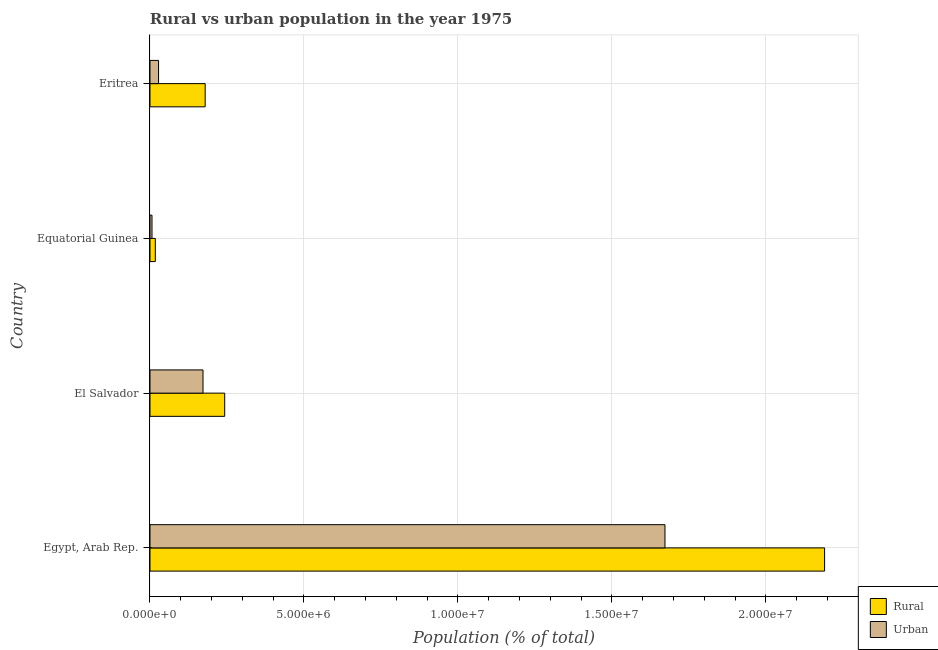How many different coloured bars are there?
Your answer should be very brief. 2. How many groups of bars are there?
Provide a succinct answer. 4. What is the label of the 2nd group of bars from the top?
Make the answer very short. Equatorial Guinea. In how many cases, is the number of bars for a given country not equal to the number of legend labels?
Provide a short and direct response. 0. What is the urban population density in Eritrea?
Your response must be concise. 2.79e+05. Across all countries, what is the maximum rural population density?
Your answer should be compact. 2.19e+07. Across all countries, what is the minimum urban population density?
Offer a terse response. 6.53e+04. In which country was the urban population density maximum?
Your response must be concise. Egypt, Arab Rep. In which country was the urban population density minimum?
Make the answer very short. Equatorial Guinea. What is the total urban population density in the graph?
Provide a succinct answer. 1.88e+07. What is the difference between the rural population density in El Salvador and that in Eritrea?
Your answer should be very brief. 6.34e+05. What is the difference between the urban population density in Eritrea and the rural population density in Egypt, Arab Rep.?
Make the answer very short. -2.16e+07. What is the average rural population density per country?
Give a very brief answer. 6.57e+06. What is the difference between the rural population density and urban population density in Eritrea?
Keep it short and to the point. 1.51e+06. In how many countries, is the rural population density greater than 8000000 %?
Ensure brevity in your answer.  1. What is the ratio of the urban population density in El Salvador to that in Equatorial Guinea?
Provide a succinct answer. 26.36. Is the rural population density in Egypt, Arab Rep. less than that in El Salvador?
Ensure brevity in your answer.  No. What is the difference between the highest and the second highest rural population density?
Your answer should be very brief. 1.95e+07. What is the difference between the highest and the lowest urban population density?
Your answer should be compact. 1.67e+07. In how many countries, is the rural population density greater than the average rural population density taken over all countries?
Keep it short and to the point. 1. Is the sum of the urban population density in Egypt, Arab Rep. and Equatorial Guinea greater than the maximum rural population density across all countries?
Give a very brief answer. No. What does the 1st bar from the top in Egypt, Arab Rep. represents?
Give a very brief answer. Urban. What does the 2nd bar from the bottom in Eritrea represents?
Offer a terse response. Urban. Are all the bars in the graph horizontal?
Provide a short and direct response. Yes. What is the difference between two consecutive major ticks on the X-axis?
Your answer should be very brief. 5.00e+06. Are the values on the major ticks of X-axis written in scientific E-notation?
Keep it short and to the point. Yes. Does the graph contain any zero values?
Ensure brevity in your answer.  No. Where does the legend appear in the graph?
Give a very brief answer. Bottom right. How are the legend labels stacked?
Provide a succinct answer. Vertical. What is the title of the graph?
Make the answer very short. Rural vs urban population in the year 1975. What is the label or title of the X-axis?
Provide a succinct answer. Population (% of total). What is the label or title of the Y-axis?
Make the answer very short. Country. What is the Population (% of total) in Rural in Egypt, Arab Rep.?
Offer a very short reply. 2.19e+07. What is the Population (% of total) in Urban in Egypt, Arab Rep.?
Keep it short and to the point. 1.67e+07. What is the Population (% of total) of Rural in El Salvador?
Provide a short and direct response. 2.43e+06. What is the Population (% of total) of Urban in El Salvador?
Offer a terse response. 1.72e+06. What is the Population (% of total) in Rural in Equatorial Guinea?
Ensure brevity in your answer.  1.73e+05. What is the Population (% of total) of Urban in Equatorial Guinea?
Provide a succinct answer. 6.53e+04. What is the Population (% of total) of Rural in Eritrea?
Provide a short and direct response. 1.79e+06. What is the Population (% of total) in Urban in Eritrea?
Offer a very short reply. 2.79e+05. Across all countries, what is the maximum Population (% of total) of Rural?
Your answer should be compact. 2.19e+07. Across all countries, what is the maximum Population (% of total) in Urban?
Keep it short and to the point. 1.67e+07. Across all countries, what is the minimum Population (% of total) of Rural?
Make the answer very short. 1.73e+05. Across all countries, what is the minimum Population (% of total) of Urban?
Offer a very short reply. 6.53e+04. What is the total Population (% of total) of Rural in the graph?
Provide a succinct answer. 2.63e+07. What is the total Population (% of total) in Urban in the graph?
Give a very brief answer. 1.88e+07. What is the difference between the Population (% of total) in Rural in Egypt, Arab Rep. and that in El Salvador?
Provide a short and direct response. 1.95e+07. What is the difference between the Population (% of total) of Urban in Egypt, Arab Rep. and that in El Salvador?
Offer a terse response. 1.50e+07. What is the difference between the Population (% of total) in Rural in Egypt, Arab Rep. and that in Equatorial Guinea?
Your answer should be compact. 2.17e+07. What is the difference between the Population (% of total) in Urban in Egypt, Arab Rep. and that in Equatorial Guinea?
Give a very brief answer. 1.67e+07. What is the difference between the Population (% of total) of Rural in Egypt, Arab Rep. and that in Eritrea?
Keep it short and to the point. 2.01e+07. What is the difference between the Population (% of total) in Urban in Egypt, Arab Rep. and that in Eritrea?
Your response must be concise. 1.64e+07. What is the difference between the Population (% of total) in Rural in El Salvador and that in Equatorial Guinea?
Offer a very short reply. 2.25e+06. What is the difference between the Population (% of total) of Urban in El Salvador and that in Equatorial Guinea?
Keep it short and to the point. 1.66e+06. What is the difference between the Population (% of total) of Rural in El Salvador and that in Eritrea?
Make the answer very short. 6.34e+05. What is the difference between the Population (% of total) of Urban in El Salvador and that in Eritrea?
Give a very brief answer. 1.44e+06. What is the difference between the Population (% of total) in Rural in Equatorial Guinea and that in Eritrea?
Offer a terse response. -1.62e+06. What is the difference between the Population (% of total) of Urban in Equatorial Guinea and that in Eritrea?
Your answer should be very brief. -2.13e+05. What is the difference between the Population (% of total) in Rural in Egypt, Arab Rep. and the Population (% of total) in Urban in El Salvador?
Offer a terse response. 2.02e+07. What is the difference between the Population (% of total) in Rural in Egypt, Arab Rep. and the Population (% of total) in Urban in Equatorial Guinea?
Your response must be concise. 2.18e+07. What is the difference between the Population (% of total) in Rural in Egypt, Arab Rep. and the Population (% of total) in Urban in Eritrea?
Offer a terse response. 2.16e+07. What is the difference between the Population (% of total) of Rural in El Salvador and the Population (% of total) of Urban in Equatorial Guinea?
Give a very brief answer. 2.36e+06. What is the difference between the Population (% of total) of Rural in El Salvador and the Population (% of total) of Urban in Eritrea?
Ensure brevity in your answer.  2.15e+06. What is the difference between the Population (% of total) of Rural in Equatorial Guinea and the Population (% of total) of Urban in Eritrea?
Give a very brief answer. -1.06e+05. What is the average Population (% of total) in Rural per country?
Provide a short and direct response. 6.57e+06. What is the average Population (% of total) of Urban per country?
Offer a very short reply. 4.70e+06. What is the difference between the Population (% of total) of Rural and Population (% of total) of Urban in Egypt, Arab Rep.?
Your response must be concise. 5.18e+06. What is the difference between the Population (% of total) in Rural and Population (% of total) in Urban in El Salvador?
Provide a short and direct response. 7.04e+05. What is the difference between the Population (% of total) of Rural and Population (% of total) of Urban in Equatorial Guinea?
Your response must be concise. 1.08e+05. What is the difference between the Population (% of total) of Rural and Population (% of total) of Urban in Eritrea?
Keep it short and to the point. 1.51e+06. What is the ratio of the Population (% of total) in Rural in Egypt, Arab Rep. to that in El Salvador?
Make the answer very short. 9.03. What is the ratio of the Population (% of total) of Urban in Egypt, Arab Rep. to that in El Salvador?
Ensure brevity in your answer.  9.71. What is the ratio of the Population (% of total) in Rural in Egypt, Arab Rep. to that in Equatorial Guinea?
Provide a succinct answer. 126.66. What is the ratio of the Population (% of total) in Urban in Egypt, Arab Rep. to that in Equatorial Guinea?
Offer a terse response. 256.05. What is the ratio of the Population (% of total) of Rural in Egypt, Arab Rep. to that in Eritrea?
Your answer should be very brief. 12.23. What is the ratio of the Population (% of total) of Urban in Egypt, Arab Rep. to that in Eritrea?
Your answer should be compact. 60.04. What is the ratio of the Population (% of total) in Rural in El Salvador to that in Equatorial Guinea?
Offer a terse response. 14.03. What is the ratio of the Population (% of total) of Urban in El Salvador to that in Equatorial Guinea?
Keep it short and to the point. 26.36. What is the ratio of the Population (% of total) of Rural in El Salvador to that in Eritrea?
Your response must be concise. 1.35. What is the ratio of the Population (% of total) in Urban in El Salvador to that in Eritrea?
Offer a very short reply. 6.18. What is the ratio of the Population (% of total) in Rural in Equatorial Guinea to that in Eritrea?
Ensure brevity in your answer.  0.1. What is the ratio of the Population (% of total) of Urban in Equatorial Guinea to that in Eritrea?
Your response must be concise. 0.23. What is the difference between the highest and the second highest Population (% of total) of Rural?
Offer a terse response. 1.95e+07. What is the difference between the highest and the second highest Population (% of total) of Urban?
Your answer should be compact. 1.50e+07. What is the difference between the highest and the lowest Population (% of total) in Rural?
Offer a very short reply. 2.17e+07. What is the difference between the highest and the lowest Population (% of total) in Urban?
Offer a very short reply. 1.67e+07. 